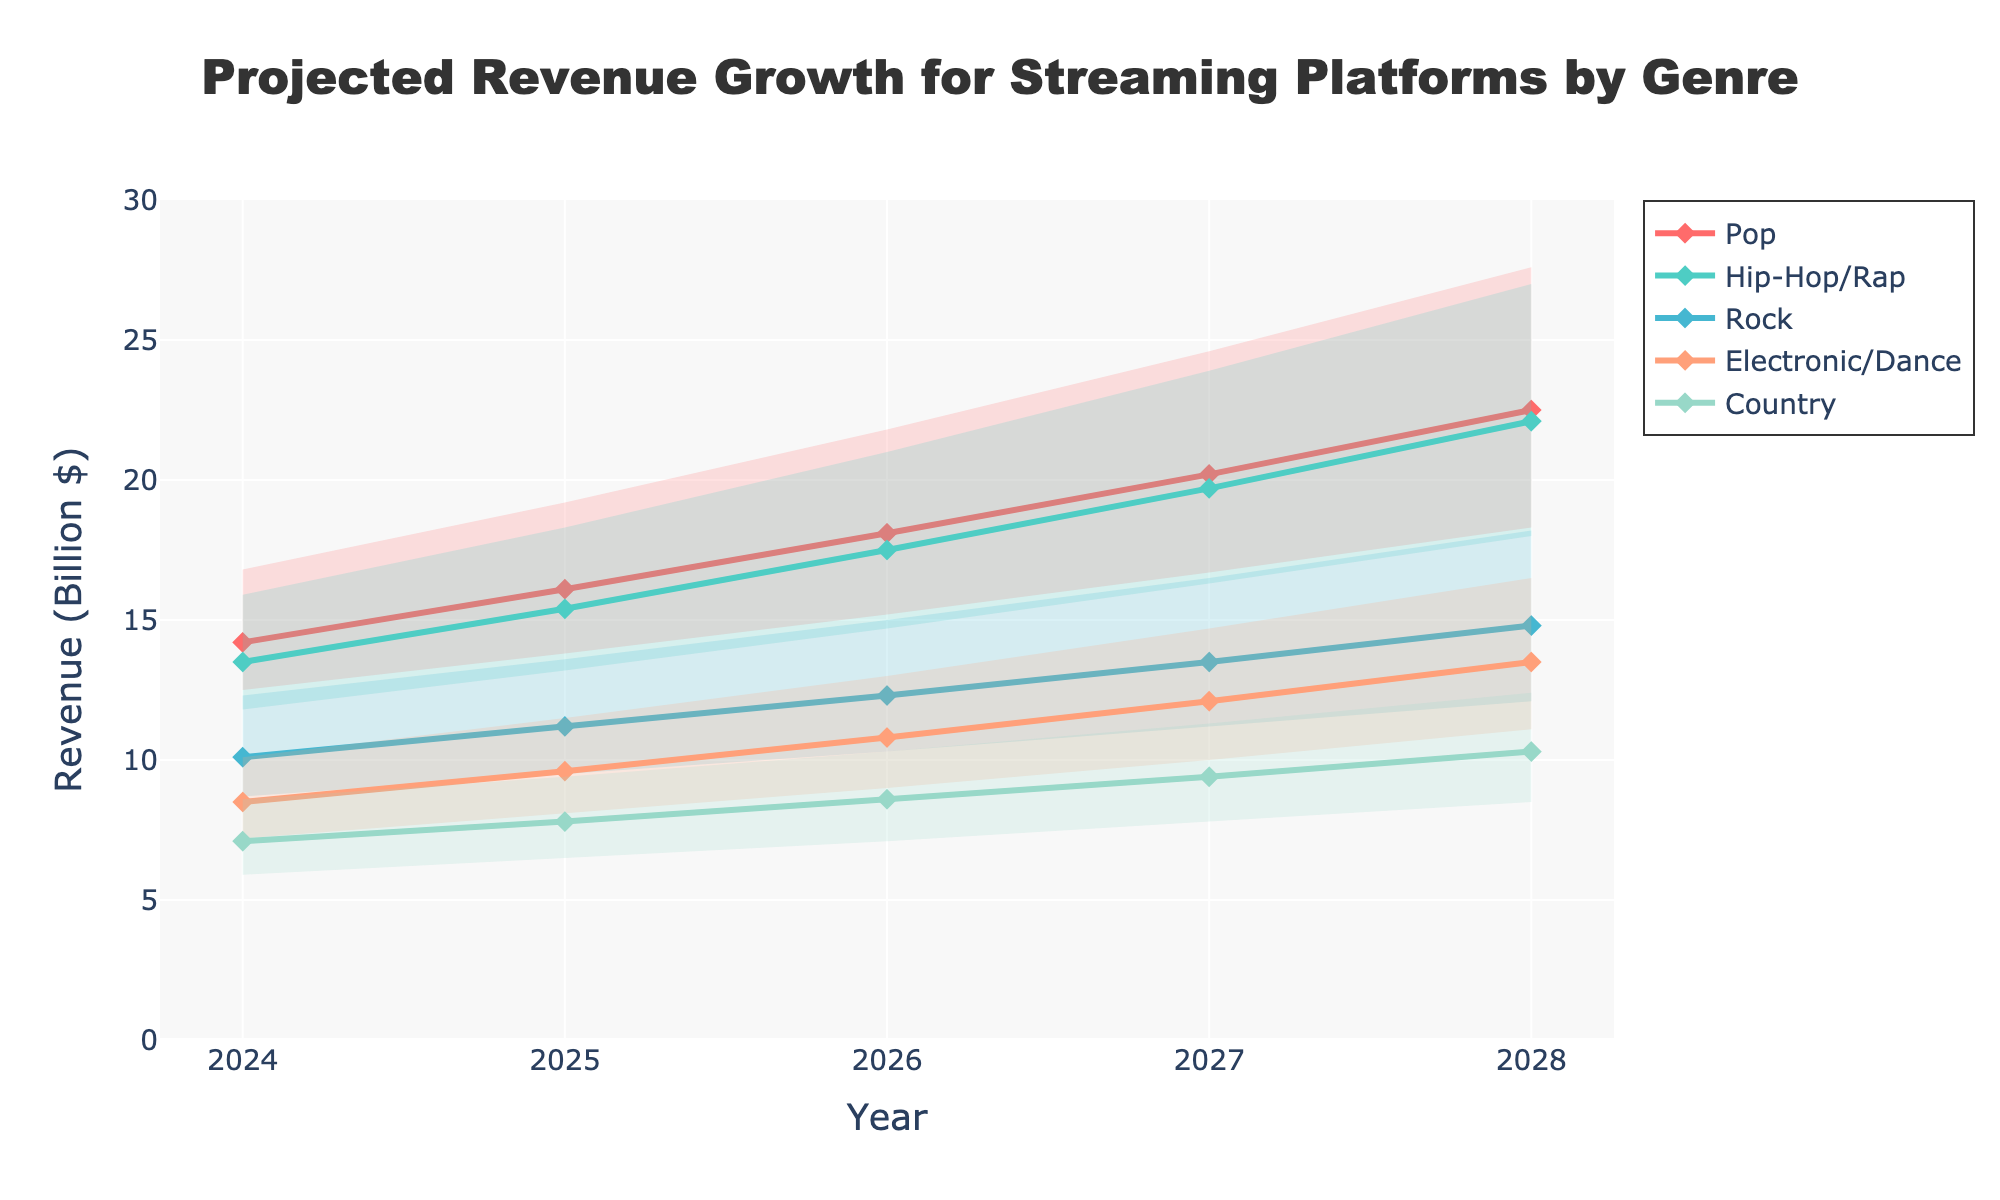What genre has the highest projected mid estimate revenue in 2028? To find the genre with the highest projected mid estimate revenue in 2028, look at the 'Mid Estimate' values for each genre in 2028 and identify the largest number.
Answer: Pop Which genre is projected to have the lowest high estimate revenue in 2028? Compare the 'High Estimate' values for all genres in 2028 to determine the smallest high estimate.
Answer: Country What is the projected mid estimate revenue for Hip-Hop/Rap in 2026? Locate the 'Mid Estimate' for the Hip-Hop/Rap genre in the year 2026 from the chart.
Answer: 17.5 By how much is the mid estimate revenue for Pop expected to grow from 2024 to 2028? Subtract the mid estimate revenue of Pop in 2024 from the mid estimate revenue of Pop in 2028: 22.5 - 14.2.
Answer: 8.3 Which genre in 2027 has a mid estimate revenue closest to 13 billion dollars? Examine the 'Mid Estimate' values for each genre in 2027 and identify the closest value to 13 billion dollars.
Answer: Rock What is the total projected low estimate revenue for all genres combined in 2025? Sum the 'Low Estimate' values for all genres in 2025: 13.8 + 13.2 + 9.5 + 8.1 + 6.5.
Answer: 51.1 Which genre shows the steepest increase in high estimate revenue from 2024 to 2028? Calculate the difference in 'High Estimate' revenue for each genre between 2024 and 2028 and identify the largest increase: Pop = 27.6-16.8, Hip-Hop/Rap = 27.0-15.9, Rock = 18.2-12.3, Electronic/Dance = 16.5-10.1, Country = 12.4-8.6.
Answer: Pop What year is the mid estimate revenue for Electronic/Dance expected to surpass 10 billion dollars? Locate the year where the mid estimate for the Electronic/Dance genre exceeds 10 billion dollars.
Answer: 2026 How does the projected revenue range (difference between high and low estimates) for Rock in 2025 compare to the range in 2028? Calculate the difference between high and low estimates for Rock in 2025 (13.6 - 9.5) and for Rock in 2028 (18.2 - 12.1) and compare the two ranges.
Answer: 4.1 lower in 2025, 6.1 in 2028 